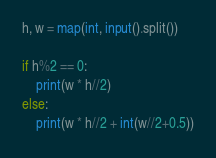Convert code to text. <code><loc_0><loc_0><loc_500><loc_500><_Python_>h, w = map(int, input().split())

if h%2 == 0:
    print(w * h//2)
else:
    print(w * h//2 + int(w//2+0.5))</code> 